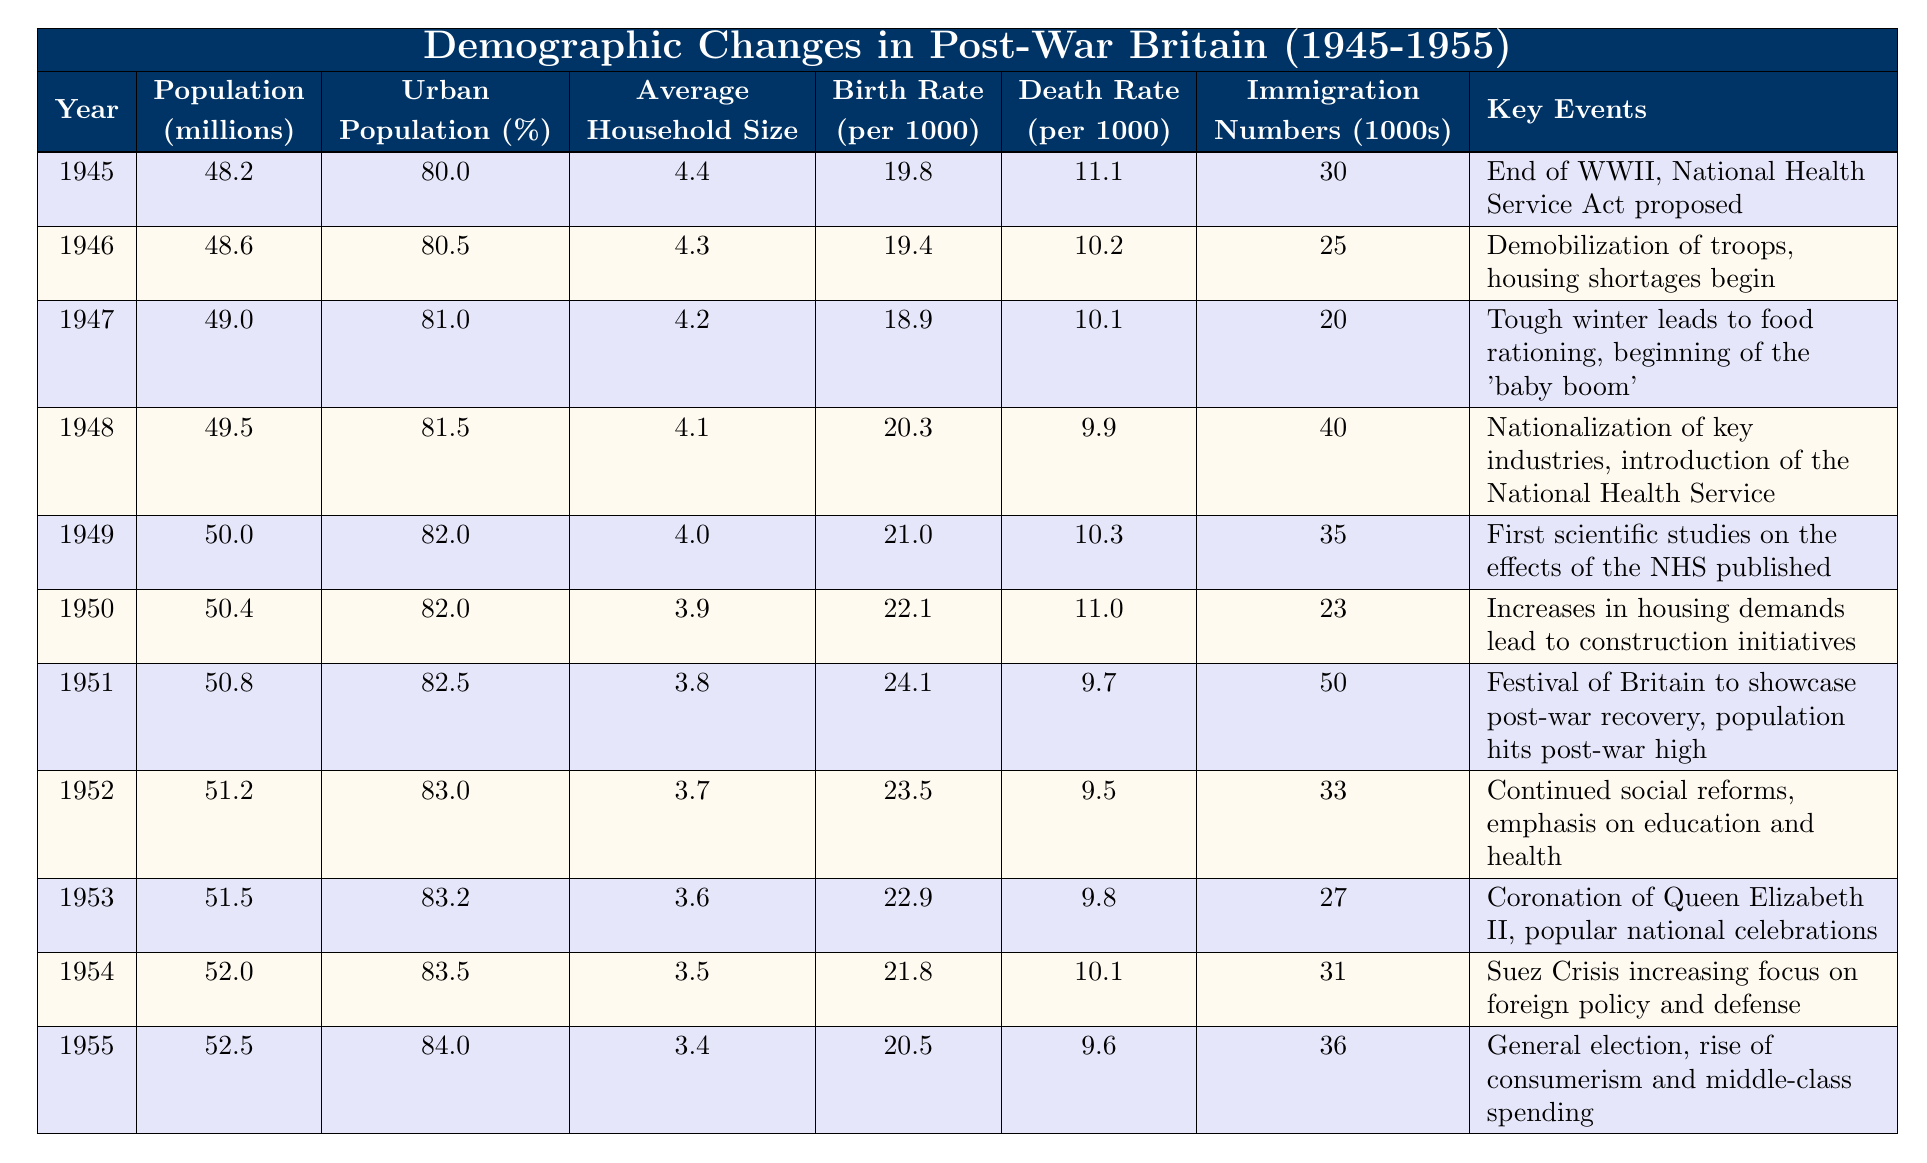What was the population of Britain in 1951? In the table, the row for the year 1951 shows a population of 50.8 million.
Answer: 50.8 million Which year had the highest birth rate? Looking through the birth rate values, 1951 has the highest birth rate at 24.1 per 1000.
Answer: 1951 What was the average household size in 1945 compared to 1955? In 1945, the average household size was 4.4, and in 1955 it was 3.4, showing a decrease.
Answer: 4.4 (in 1945) and 3.4 (in 1955) Did the urban population percentage increase or decrease from 1945 to 1955? The urban population percentage increased from 80% in 1945 to 84% in 1955, indicating an increase.
Answer: Increased What was the change in immigration numbers from 1948 to 1950? In 1948, immigration numbers were 40, and in 1950, they dropped to 23, showing a decrease of 17.
Answer: Decreased by 17 What was the average death rate from 1945 to 1955? Summing the death rates from each year (11.1 + 10.2 + 10.1 + 9.9 + 10.3 + 11.0 + 9.7 + 9.5 + 9.8 + 10.1 + 9.6) gives a total of 110.7 over 11 years, which results in an average death rate of about 10.07.
Answer: Approximately 10.07 In which year did the gap between the birth rate and death rate become the largest? Comparing the difference between birth rate and death rate, the largest gap occurs in 1951 (birth rate 24.1 and death rate 9.7), which shows a difference of 14.4.
Answer: 1951 Was there a noticeable trend in the average household size from 1945 to 1955? The average household size decreased steadily from 4.4 in 1945 to 3.4 in 1955, indicating a downward trend.
Answer: Yes, it decreased What was the total population increase from 1945 to 1955? The population in 1945 was 48.2 million and in 1955 it was 52.5 million. The increase is 52.5 - 48.2 = 4.3 million.
Answer: 4.3 million Which year had the lowest death rate, and what was it? The year with the lowest death rate was 1952, at 9.5 per 1000.
Answer: 1952, 9.5 per 1000 How much did the percentage of the urban population grow per year on average from 1945 to 1955? The urban population percentage grew from 80% to 84% over 10 years, resulting in an average growth of 0.4% per year (4% / 10 years).
Answer: 0.4% per year 